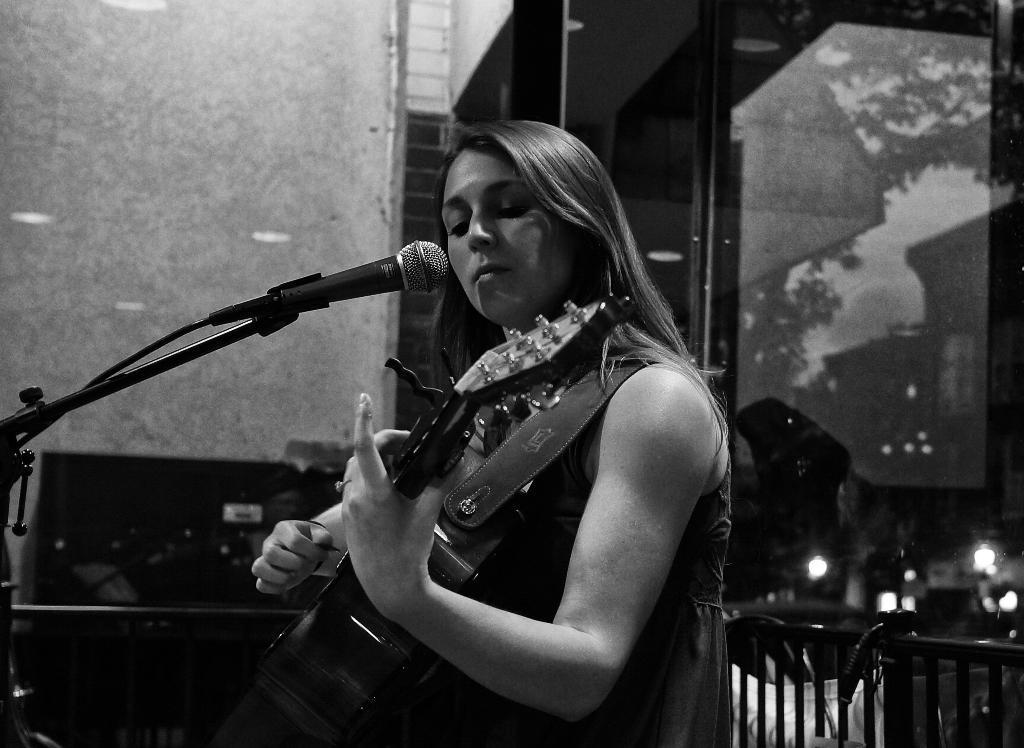Describe this image in one or two sentences. In this there is a woman, playing a guitar in her hands. There is a microphone and a stand in front of her. In the background there is a wall. 